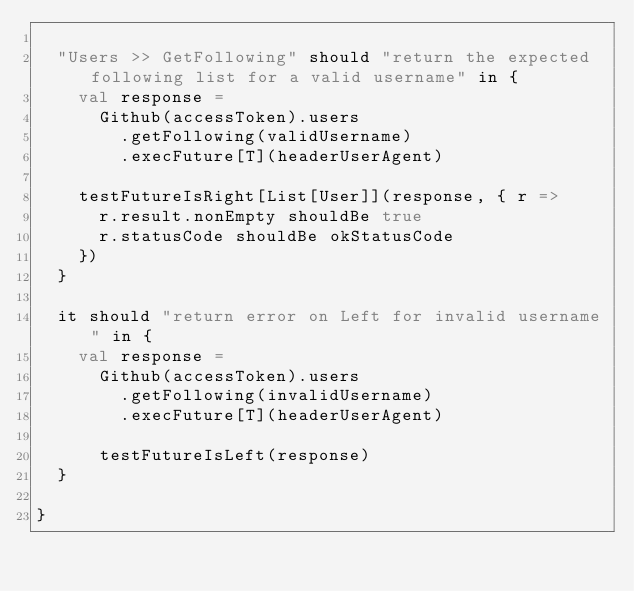<code> <loc_0><loc_0><loc_500><loc_500><_Scala_>
  "Users >> GetFollowing" should "return the expected following list for a valid username" in {
    val response =
      Github(accessToken).users
        .getFollowing(validUsername)
        .execFuture[T](headerUserAgent)

    testFutureIsRight[List[User]](response, { r =>
      r.result.nonEmpty shouldBe true
      r.statusCode shouldBe okStatusCode
    })
  }

  it should "return error on Left for invalid username" in {
    val response =
      Github(accessToken).users
        .getFollowing(invalidUsername)
        .execFuture[T](headerUserAgent)

      testFutureIsLeft(response)
  }  

}
</code> 